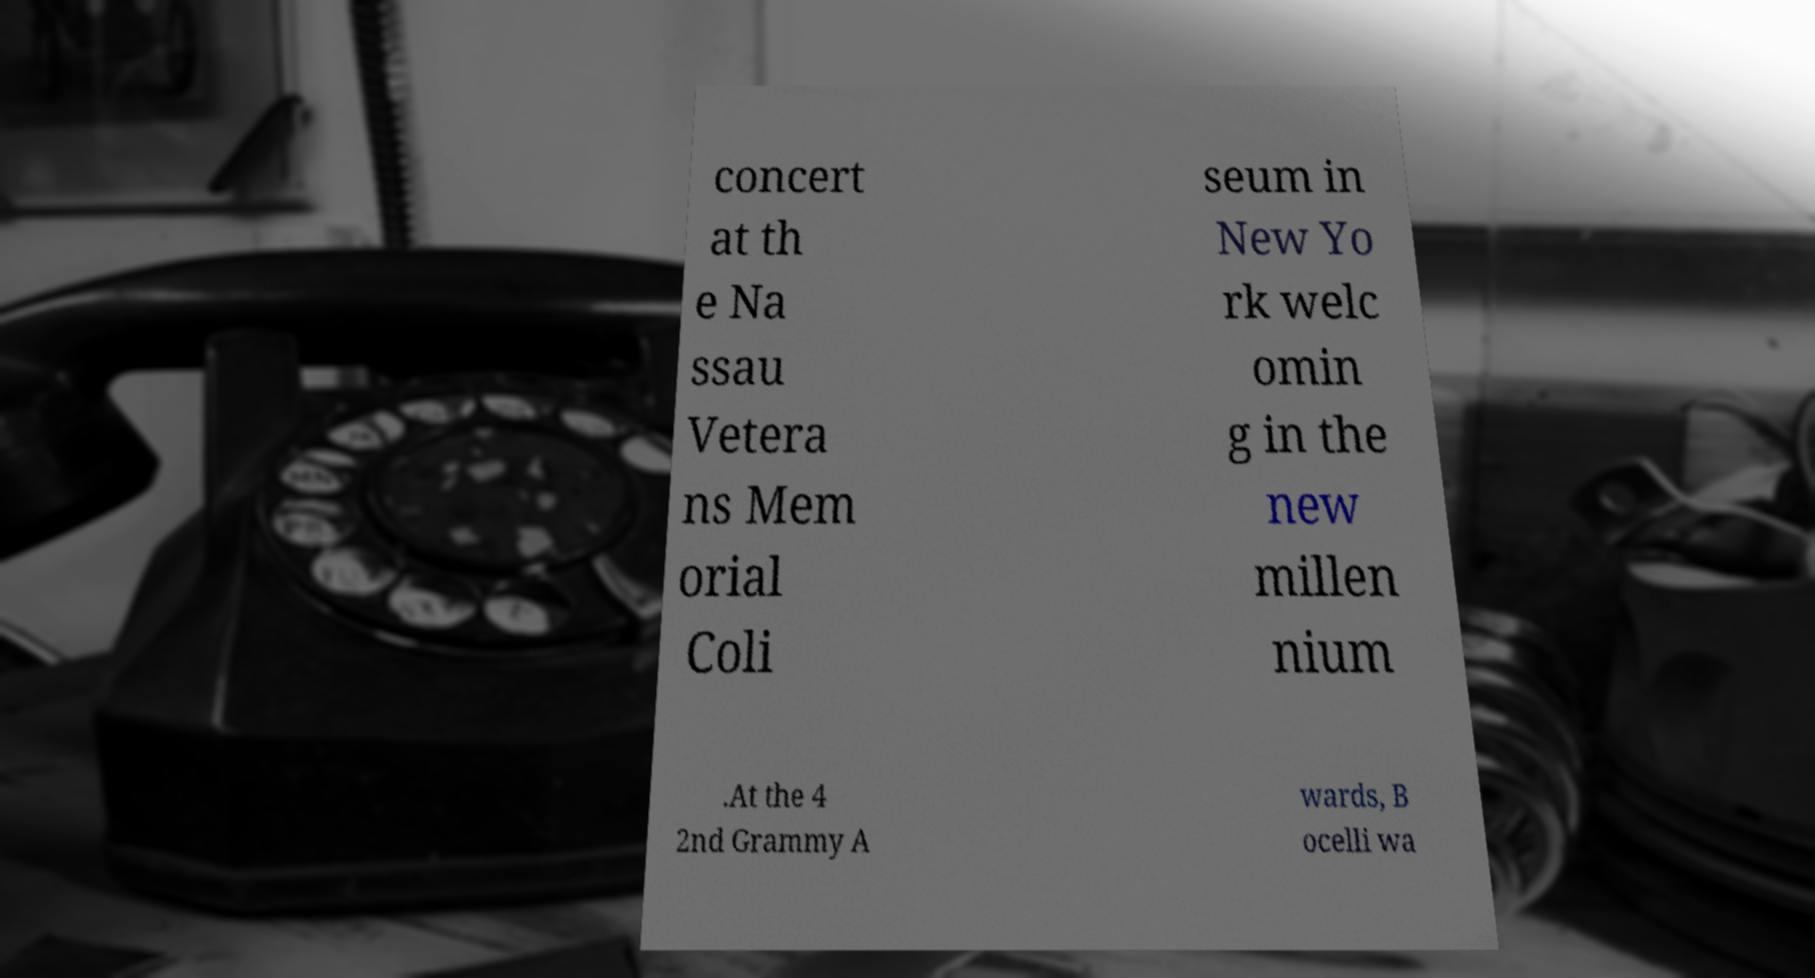Please identify and transcribe the text found in this image. concert at th e Na ssau Vetera ns Mem orial Coli seum in New Yo rk welc omin g in the new millen nium .At the 4 2nd Grammy A wards, B ocelli wa 